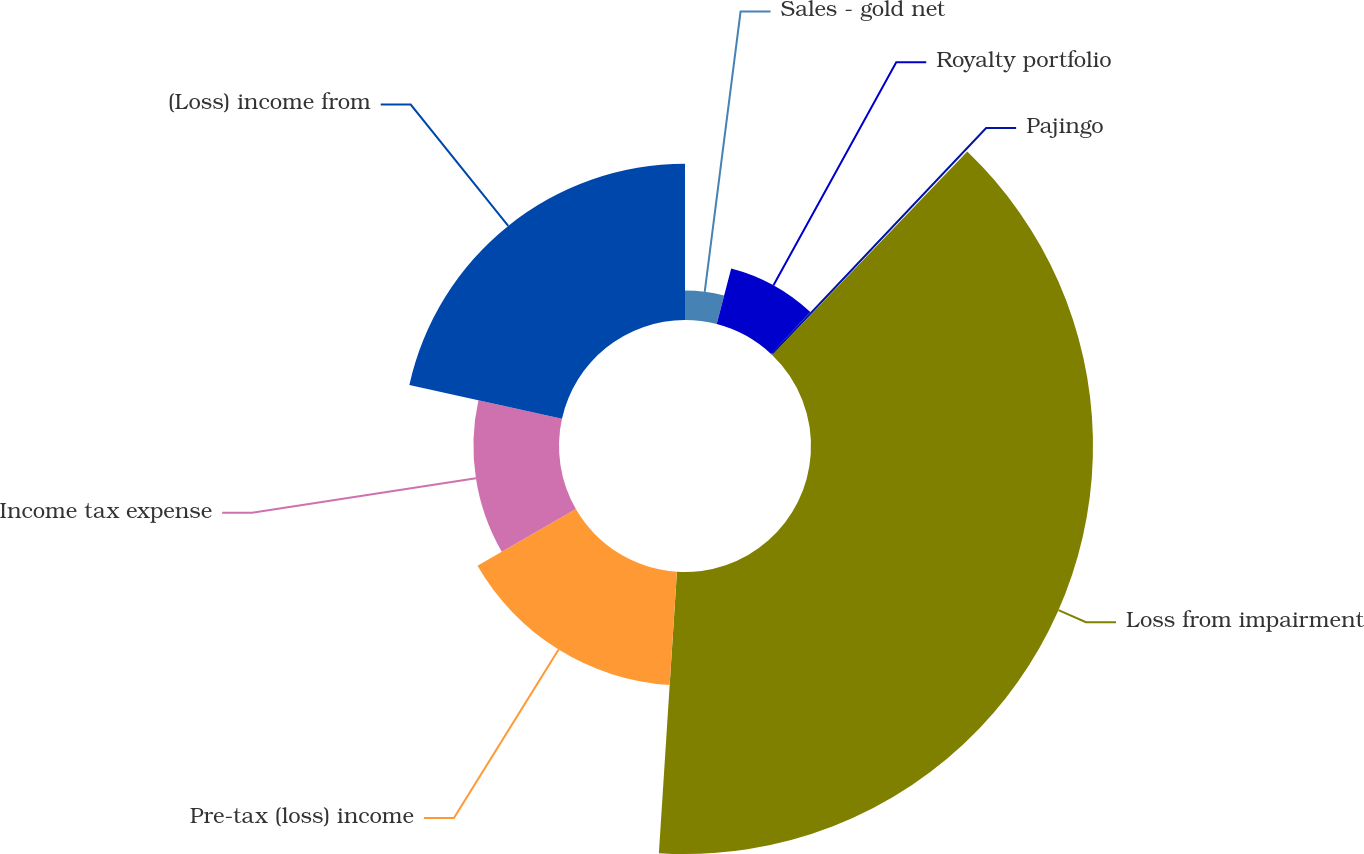<chart> <loc_0><loc_0><loc_500><loc_500><pie_chart><fcel>Sales - gold net<fcel>Royalty portfolio<fcel>Pajingo<fcel>Loss from impairment<fcel>Pre-tax (loss) income<fcel>Income tax expense<fcel>(Loss) income from<nl><fcel>4.05%<fcel>7.92%<fcel>0.19%<fcel>38.86%<fcel>15.65%<fcel>11.79%<fcel>21.54%<nl></chart> 